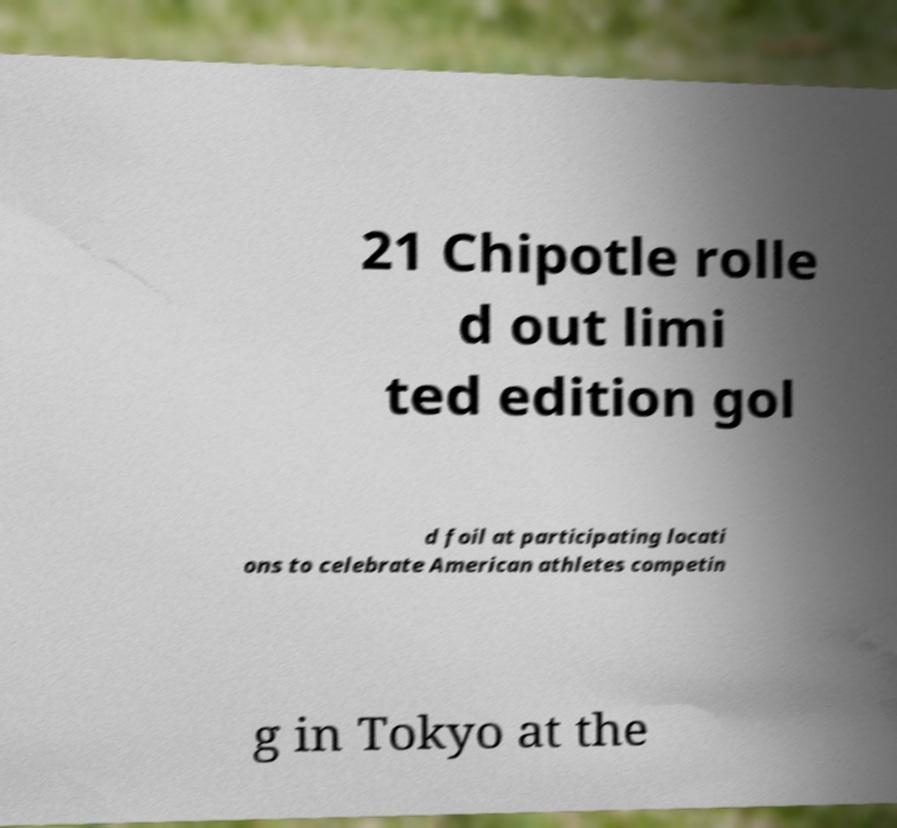There's text embedded in this image that I need extracted. Can you transcribe it verbatim? 21 Chipotle rolle d out limi ted edition gol d foil at participating locati ons to celebrate American athletes competin g in Tokyo at the 